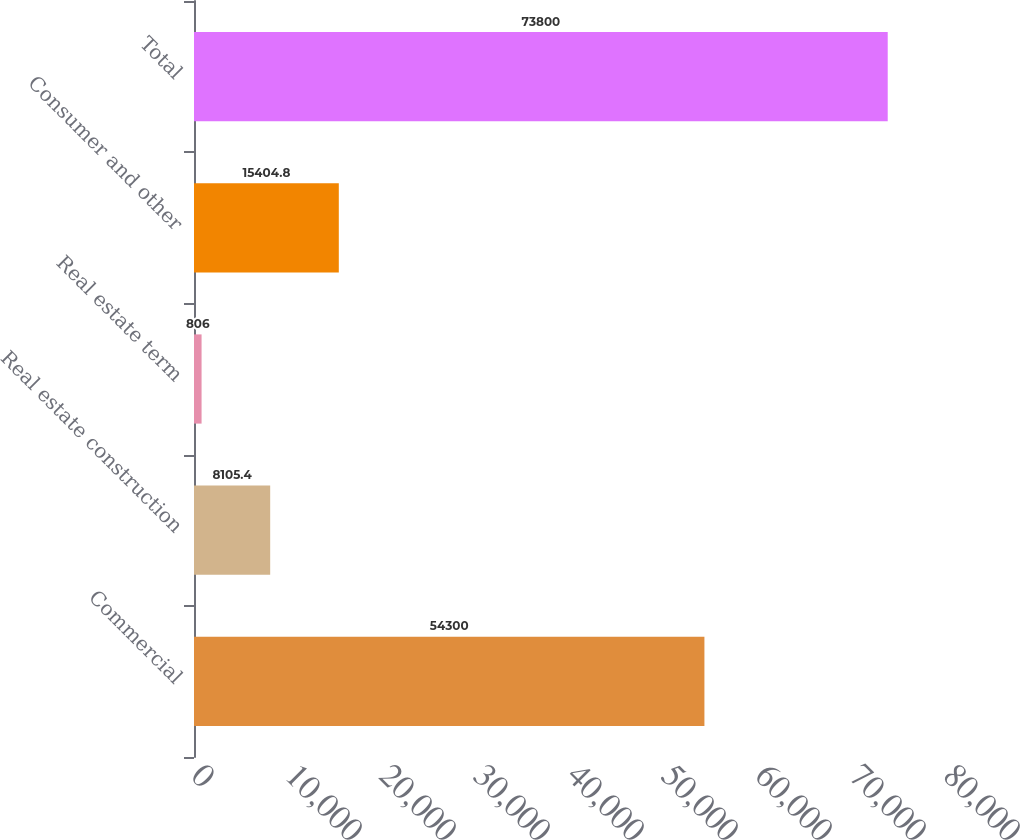<chart> <loc_0><loc_0><loc_500><loc_500><bar_chart><fcel>Commercial<fcel>Real estate construction<fcel>Real estate term<fcel>Consumer and other<fcel>Total<nl><fcel>54300<fcel>8105.4<fcel>806<fcel>15404.8<fcel>73800<nl></chart> 